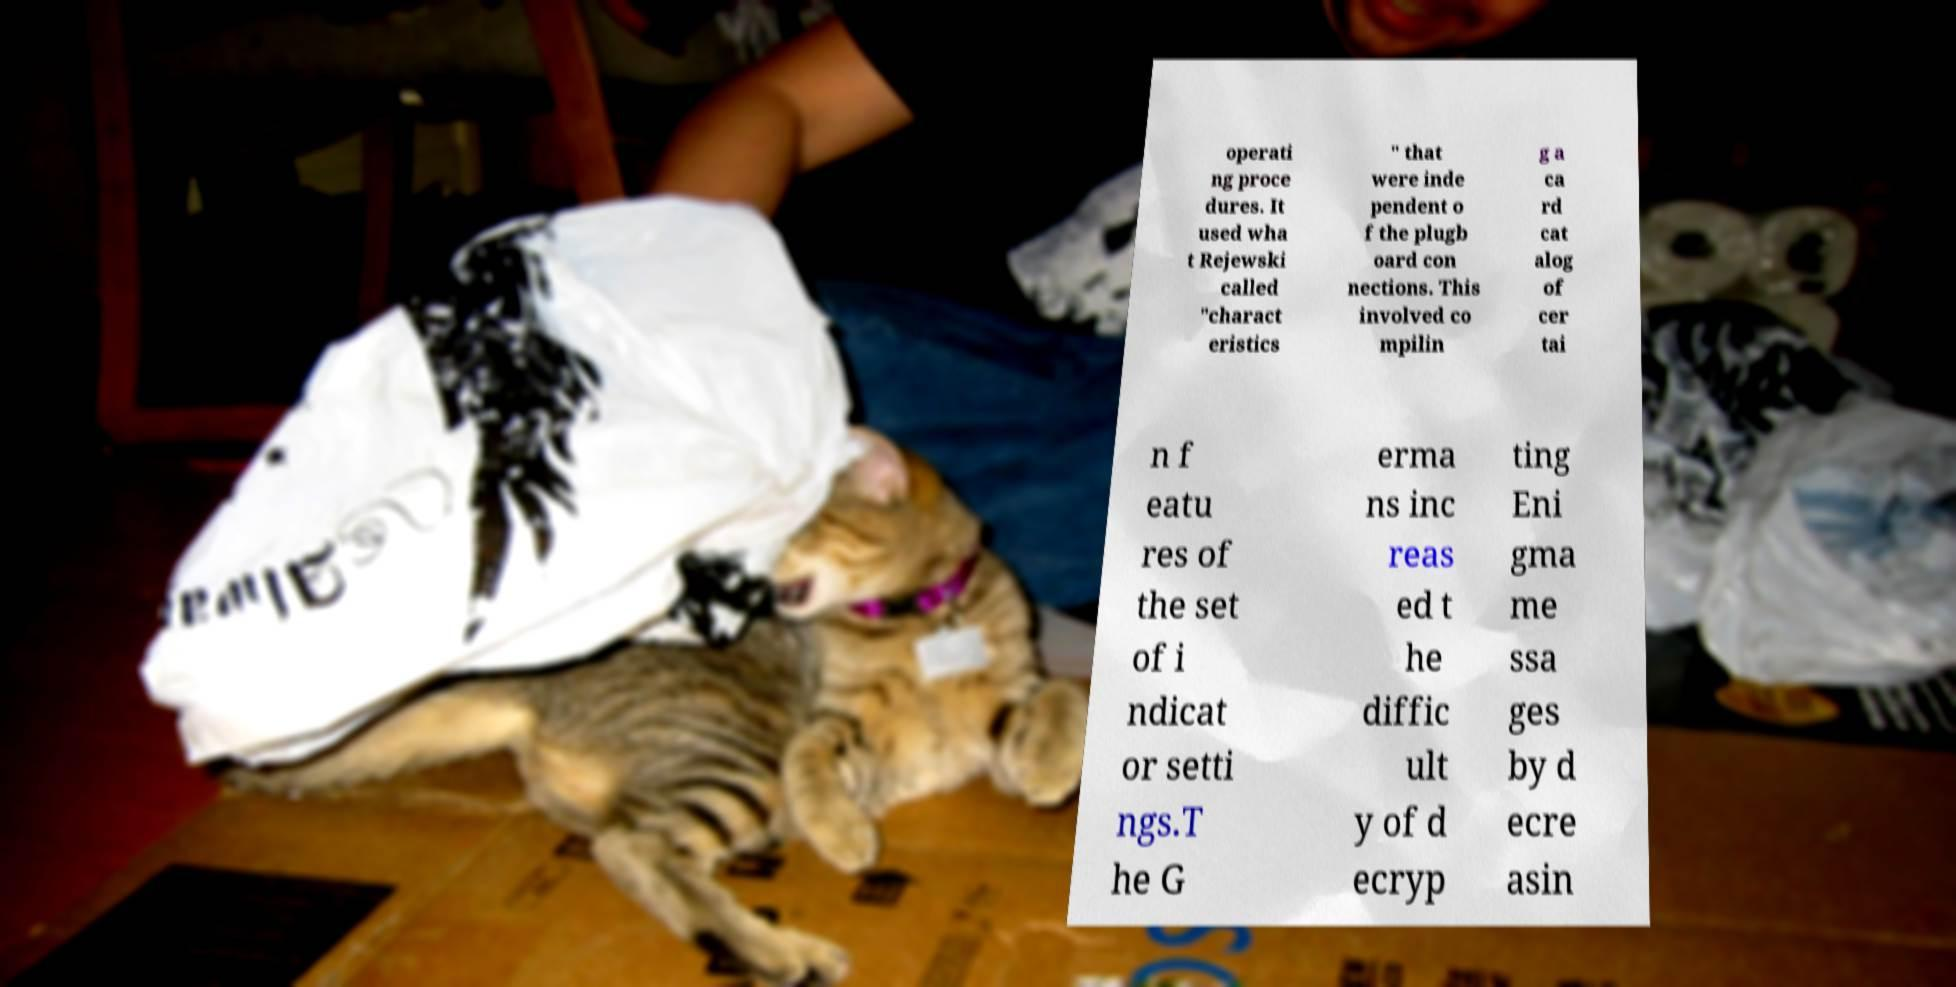Please read and relay the text visible in this image. What does it say? operati ng proce dures. It used wha t Rejewski called "charact eristics " that were inde pendent o f the plugb oard con nections. This involved co mpilin g a ca rd cat alog of cer tai n f eatu res of the set of i ndicat or setti ngs.T he G erma ns inc reas ed t he diffic ult y of d ecryp ting Eni gma me ssa ges by d ecre asin 